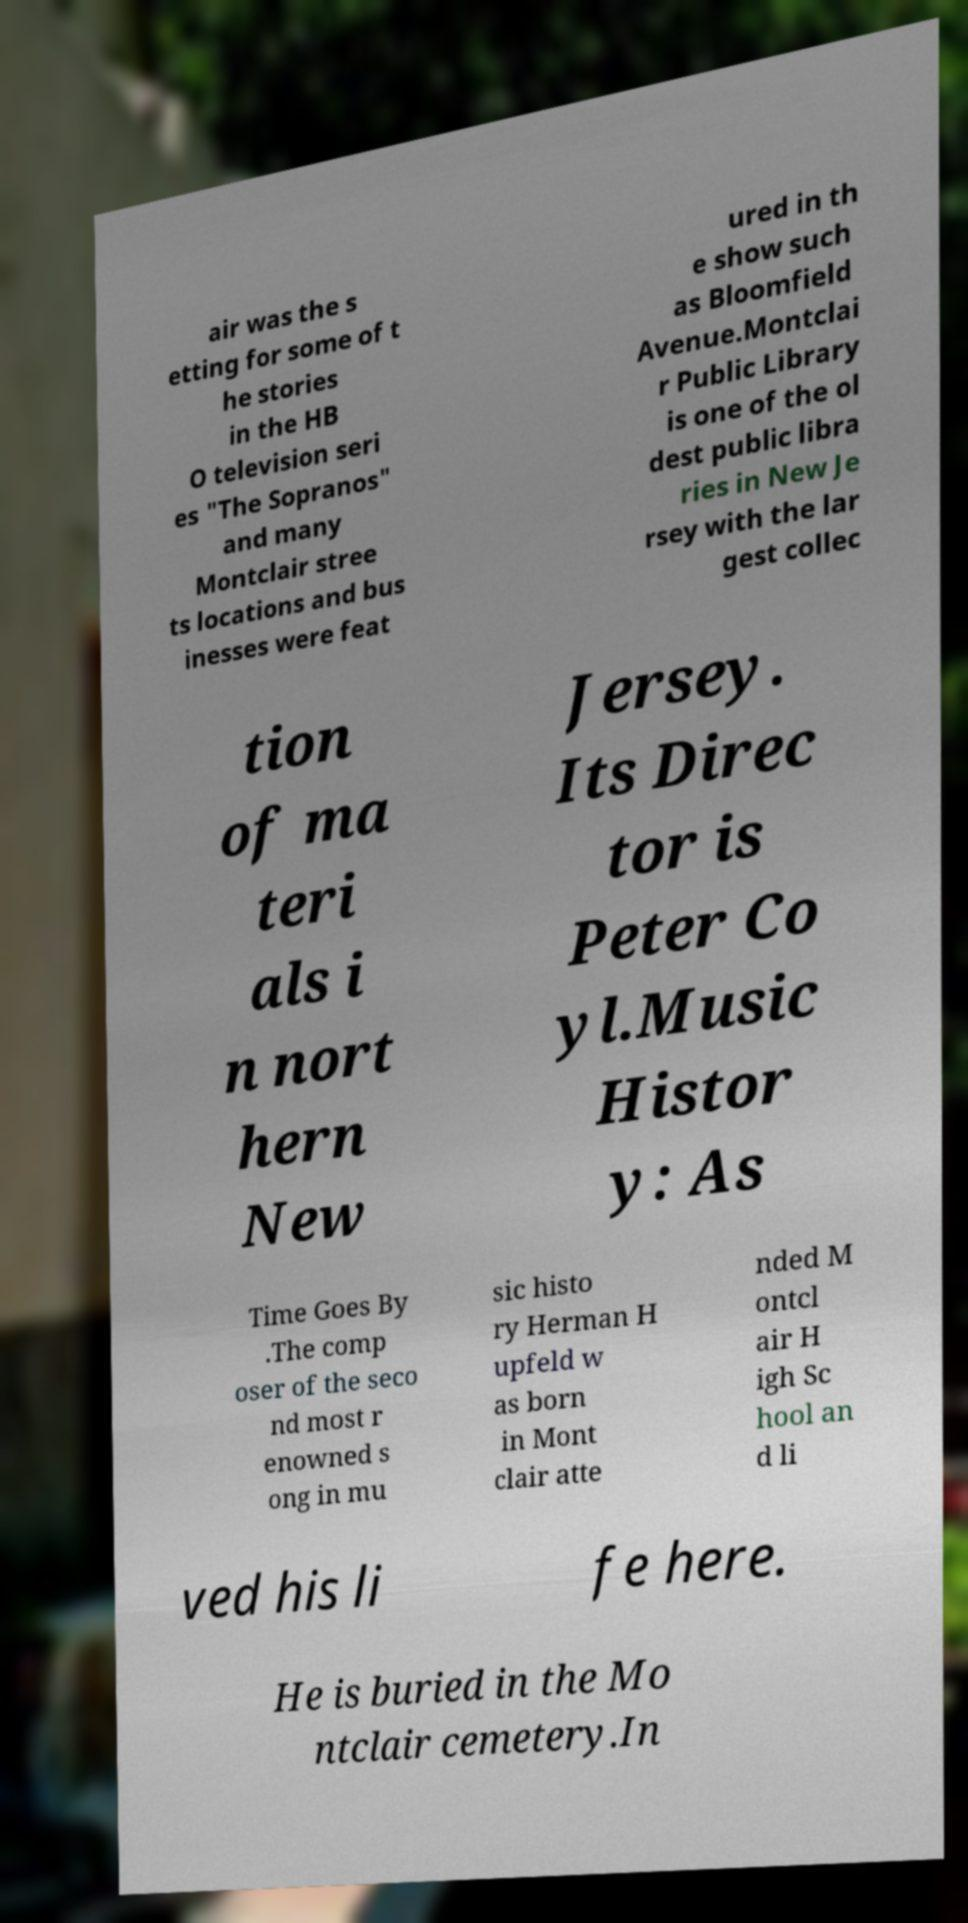What messages or text are displayed in this image? I need them in a readable, typed format. air was the s etting for some of t he stories in the HB O television seri es "The Sopranos" and many Montclair stree ts locations and bus inesses were feat ured in th e show such as Bloomfield Avenue.Montclai r Public Library is one of the ol dest public libra ries in New Je rsey with the lar gest collec tion of ma teri als i n nort hern New Jersey. Its Direc tor is Peter Co yl.Music Histor y: As Time Goes By .The comp oser of the seco nd most r enowned s ong in mu sic histo ry Herman H upfeld w as born in Mont clair atte nded M ontcl air H igh Sc hool an d li ved his li fe here. He is buried in the Mo ntclair cemetery.In 